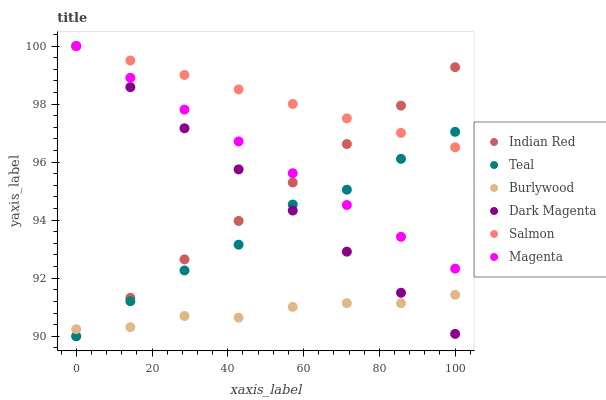Does Burlywood have the minimum area under the curve?
Answer yes or no. Yes. Does Salmon have the maximum area under the curve?
Answer yes or no. Yes. Does Salmon have the minimum area under the curve?
Answer yes or no. No. Does Burlywood have the maximum area under the curve?
Answer yes or no. No. Is Dark Magenta the smoothest?
Answer yes or no. Yes. Is Teal the roughest?
Answer yes or no. Yes. Is Burlywood the smoothest?
Answer yes or no. No. Is Burlywood the roughest?
Answer yes or no. No. Does Indian Red have the lowest value?
Answer yes or no. Yes. Does Burlywood have the lowest value?
Answer yes or no. No. Does Dark Magenta have the highest value?
Answer yes or no. Yes. Does Burlywood have the highest value?
Answer yes or no. No. Is Burlywood less than Magenta?
Answer yes or no. Yes. Is Magenta greater than Burlywood?
Answer yes or no. Yes. Does Salmon intersect Teal?
Answer yes or no. Yes. Is Salmon less than Teal?
Answer yes or no. No. Is Salmon greater than Teal?
Answer yes or no. No. Does Burlywood intersect Magenta?
Answer yes or no. No. 